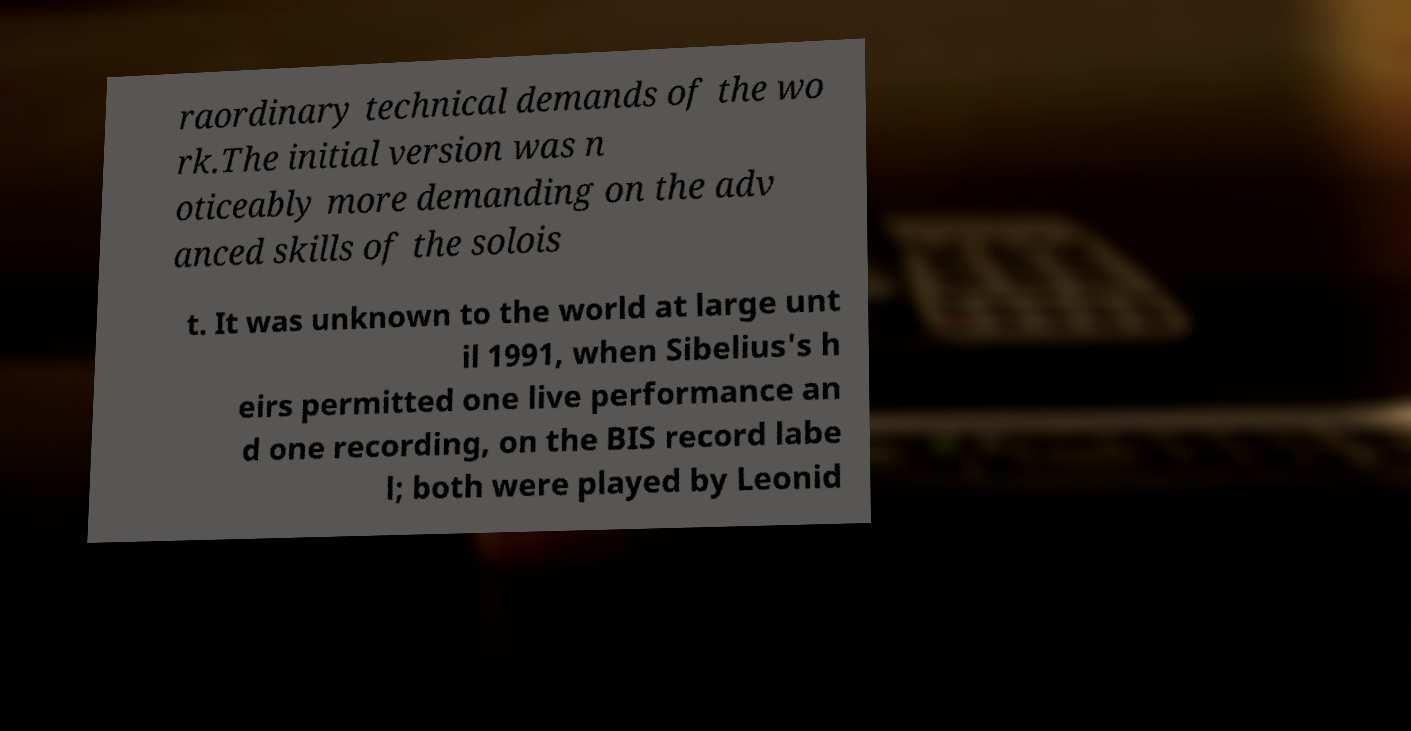For documentation purposes, I need the text within this image transcribed. Could you provide that? raordinary technical demands of the wo rk.The initial version was n oticeably more demanding on the adv anced skills of the solois t. It was unknown to the world at large unt il 1991, when Sibelius's h eirs permitted one live performance an d one recording, on the BIS record labe l; both were played by Leonid 